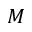<formula> <loc_0><loc_0><loc_500><loc_500>M</formula> 